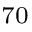Convert formula to latex. <formula><loc_0><loc_0><loc_500><loc_500>^ { 7 0 }</formula> 